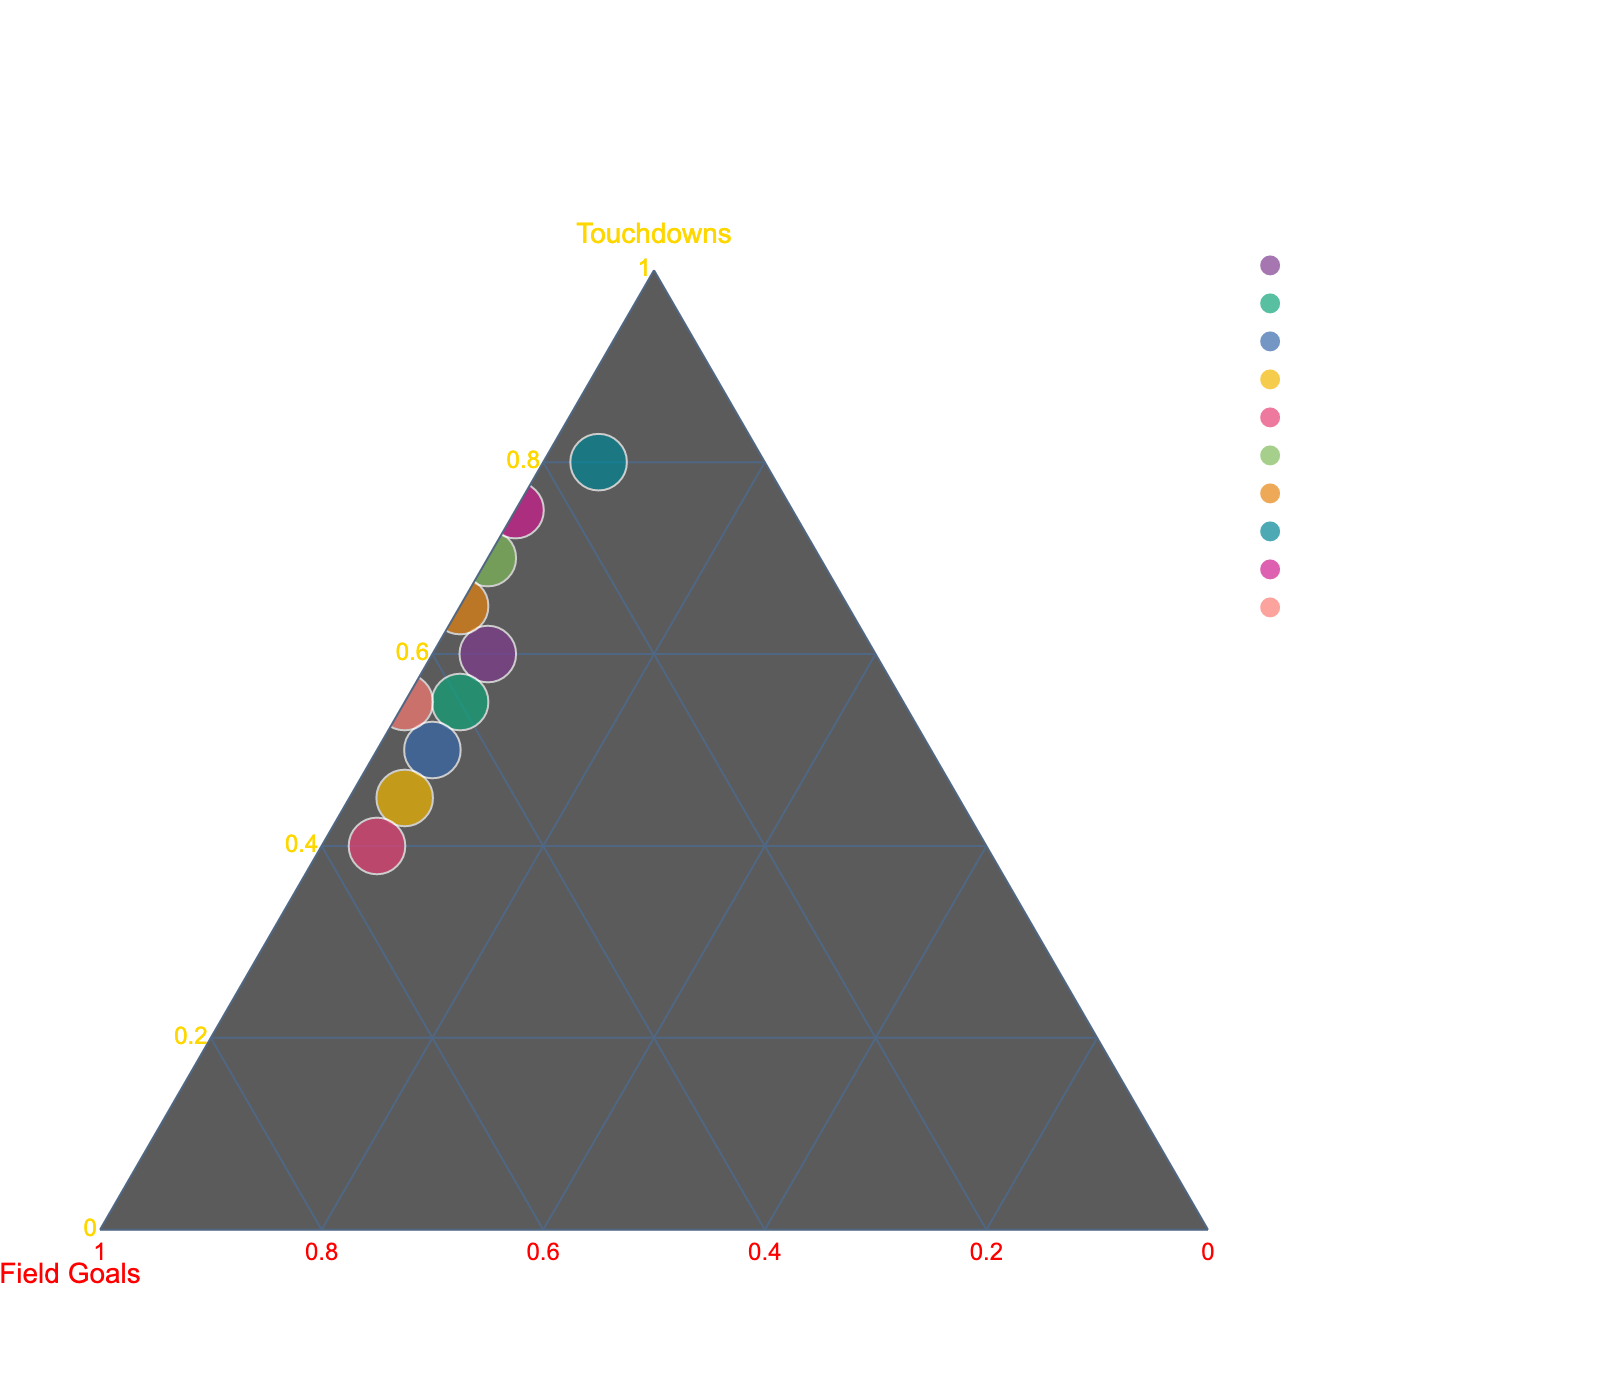How many total data points are displayed on the plot? The plot includes the data points corresponding to each quarter and special game situations. These are Q1, Q2, Q3, Q4, OT, Red Zone, Two-Minute Drill, Goal Line Stands, 3rd Down Conversions, and 4th Quarter Comebacks. Counting these gives us 10 data points.
Answer: 10 What are the titles of the axes on the ternary plot? The ternary plot has three axes: the one for Touchdowns, the one for Field Goals, and the one for Safeties.
Answer: Touchdowns, Field Goals, Safeties Which quarter or game situation has the highest percentage of Touchdowns? From the data, we see that "Goal Line Stands" has the highest percentage of Touchdowns at 80%. On the ternary plot, this data point will be positioned closer to the Touchdowns axis.
Answer: Goal Line Stands In which quarter or game situation do Field Goals account for the highest proportion of scoring? According to the data, Field Goals are highest in OT with 55%. This should be noticeable on the ternary plot as the point closest to the Field Goals axis.
Answer: OT Can you find a point where the Field Goal percentage is equal to the Touchdown percentage? On the ternary plot, look for points equidistant from the Touchdowns and Field Goals axes. Based on the given data, there is no data point where Touchdowns and Field Goals have equal values.
Answer: No What is the average percentage of Safeties across all quarters and game situations? Safeties are consistently 5% across all timeframes except for Red Zone, Two-Minute Drill, and 3rd Down Conversions, which have 0%. Calculating the average: (5+5+5+5+5+0+0+5+0+0)/10 = 3.0%.
Answer: 3.0% Which data point has the smallest percentage of Safeties, excluding values of zero? The only consistent value for Safeties is 5% where it exists. Since there’s no other positive amount specified other than 5%, all such data points share the smallest non-zero percentage of Safeties.
Answer: 5% Comparison: Are there more points with a higher percentage of Field Goals than Touchdowns or vice versa? To determine this, count the instances:
1. More Field Goals: Q4, OT, 
2. More Touchdowns: Q1, Q2, Q3, Red Zone, Two-Minute Drill, Goal Line Stands, 3rd Down Conversions, 4th Quarter Comebacks.
There are more points with a higher percentage of Touchdowns compared to Field Goals.
Answer: More points have higher percentages of Touchdowns Can you infer if any game situation has a balanced scoring distribution? A balanced scoring distribution would be close to equal percentages of Touchdowns, Field Goals, and Safeties. Observing the ternary plot, no data point seems equidistant from all three axes, which indicates no balanced scoring distribution.
Answer: No 